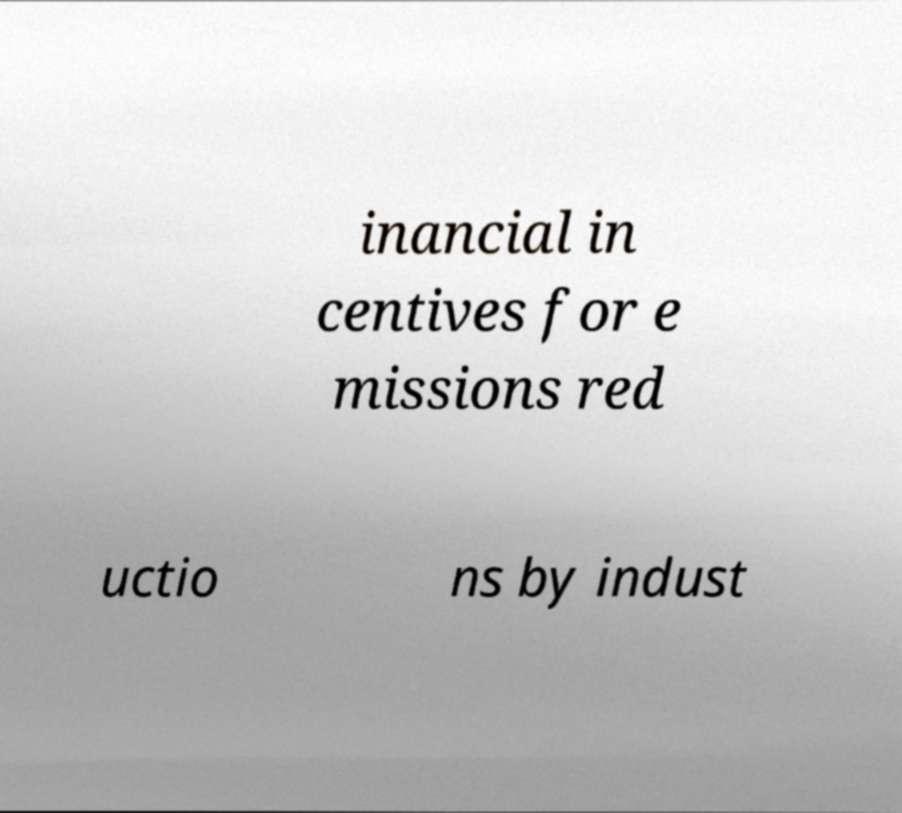Could you assist in decoding the text presented in this image and type it out clearly? inancial in centives for e missions red uctio ns by indust 